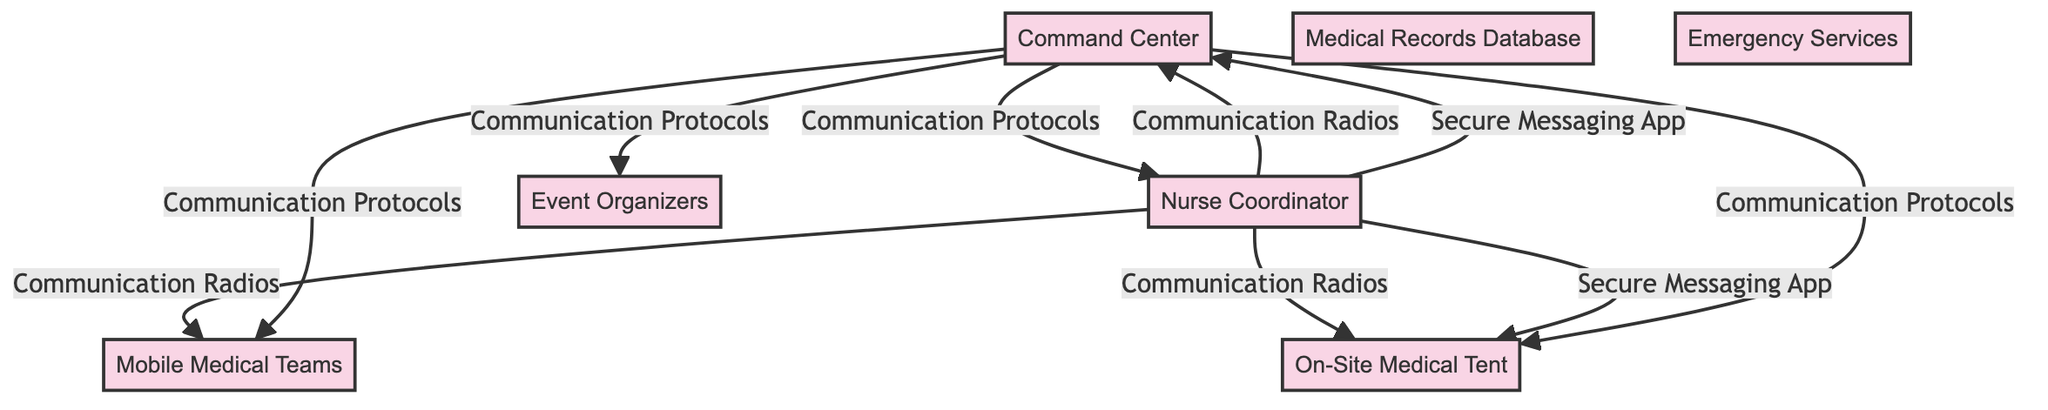What is the central hub for medical operations? The node labeled "On-Site Medical Tent" is marked as the central hub for medical operations during the charity run.
Answer: On-Site Medical Tent How many communication methods does the Nurse Coordinator use? The Nurse Coordinator communicates using two methods: Communication Radios and Secure Messaging App, connecting with multiple nodes.
Answer: Two Which node is responsible for coordinating among medical staff? The "Nurse Coordinator" is specifically described as being responsible for coordinating among medical staff.
Answer: Nurse Coordinator What is the relationship between the Command Center and Event Organizers? The Command Center communicates with the Event Organizers through predefined communication protocols for efficient communication.
Answer: Communication Protocols Which node is connected to both the Mobile Medical Teams and On-Site Medical Tent? The "Nurse Coordinator" is the node that is connected to both the Mobile Medical Teams and the On-Site Medical Tent using communication radios.
Answer: Nurse Coordinator What type of database is included in the diagram? The diagram includes a "Medical Records Database", which indicates a digital storage system for medical histories.
Answer: Medical Records Database How many nodes are there in total? There are a total of ten nodes in the diagram including both nodes and edges representing relationships and communication.
Answer: Ten What method does the Nurse Coordinator use to share sensitive information? The Nurse Coordinator uses a "Secure Messaging App" to share sensitive information quickly and securely with other nodes.
Answer: Secure Messaging App Which node receives communications from the Command Center? The nodes that receive communications from the Command Center are the Nurse Coordinator, On-Site Medical Tent, Mobile Medical Teams, and Event Organizers.
Answer: Nurse Coordinator, On-Site Medical Tent, Mobile Medical Teams, Event Organizers What are the local emergency services referred to in the diagram? The diagram mentions "Emergency Services" as the local emergency services available for severe cases requiring intervention.
Answer: Emergency Services 